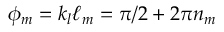Convert formula to latex. <formula><loc_0><loc_0><loc_500><loc_500>\phi _ { m } = k _ { l } \ell _ { m } = \pi / 2 + 2 \pi n _ { m }</formula> 